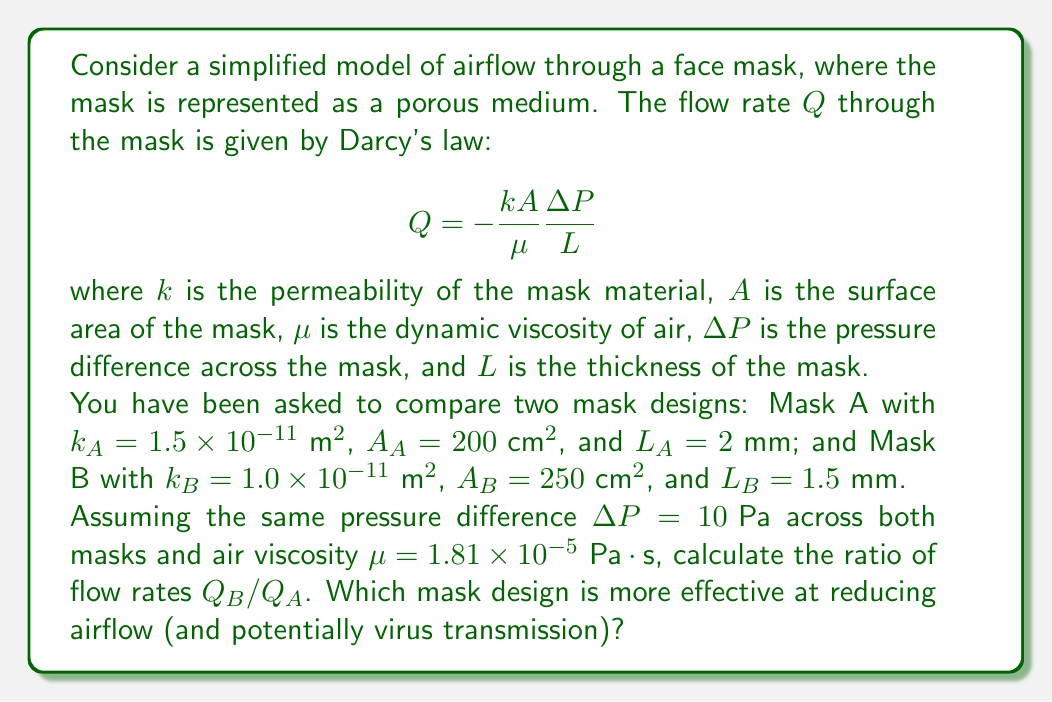Give your solution to this math problem. To solve this problem, we'll follow these steps:

1) First, let's recall Darcy's law for flow rate through a porous medium:

   $$Q = -\frac{kA}{\mu}\frac{\Delta P}{L}$$

2) We'll calculate the flow rate for each mask separately, then find their ratio.

3) For Mask A:
   $$Q_A = -\frac{k_A A_A}{\mu}\frac{\Delta P}{L_A}$$
   
   Substituting the given values:
   $$Q_A = -\frac{(1.5 \times 10^{-11} \text{ m}^2)(200 \times 10^{-4} \text{ m}^2)}{1.81 \times 10^{-5} \text{ Pa}\cdot\text{s}}\frac{10 \text{ Pa}}{2 \times 10^{-3} \text{ m}}$$

4) For Mask B:
   $$Q_B = -\frac{k_B A_B}{\mu}\frac{\Delta P}{L_B}$$
   
   Substituting the given values:
   $$Q_B = -\frac{(1.0 \times 10^{-11} \text{ m}^2)(250 \times 10^{-4} \text{ m}^2)}{1.81 \times 10^{-5} \text{ Pa}\cdot\text{s}}\frac{10 \text{ Pa}}{1.5 \times 10^{-3} \text{ m}}$$

5) Now, let's calculate the ratio $Q_B/Q_A$:

   $$\frac{Q_B}{Q_A} = \frac{k_B A_B L_A}{k_A A_A L_B}$$

6) Substituting the values:

   $$\frac{Q_B}{Q_A} = \frac{(1.0 \times 10^{-11})(250)(2 \times 10^{-3})}{(1.5 \times 10^{-11})(200)(1.5 \times 10^{-3})} = \frac{5 \times 10^{-12}}{4.5 \times 10^{-12}} = \frac{10}{9} \approx 1.11$$

7) This ratio means that Mask B allows approximately 11% more airflow than Mask A.

8) Since we want to reduce airflow (and potential virus transmission), the mask with the lower flow rate is more effective. In this case, Mask A is more effective.
Answer: The ratio of flow rates $Q_B/Q_A \approx 1.11$. Mask A is more effective at reducing airflow and potentially virus transmission. 